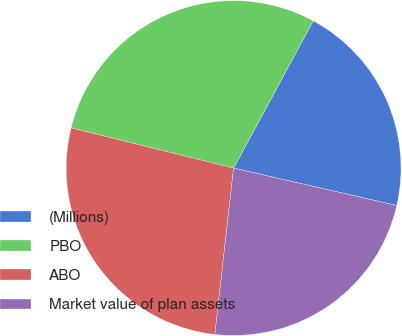<chart> <loc_0><loc_0><loc_500><loc_500><pie_chart><fcel>(Millions)<fcel>PBO<fcel>ABO<fcel>Market value of plan assets<nl><fcel>20.7%<fcel>29.03%<fcel>27.07%<fcel>23.2%<nl></chart> 